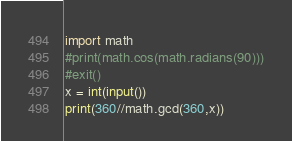<code> <loc_0><loc_0><loc_500><loc_500><_Python_>import math
#print(math.cos(math.radians(90)))
#exit()
x = int(input())
print(360//math.gcd(360,x))</code> 